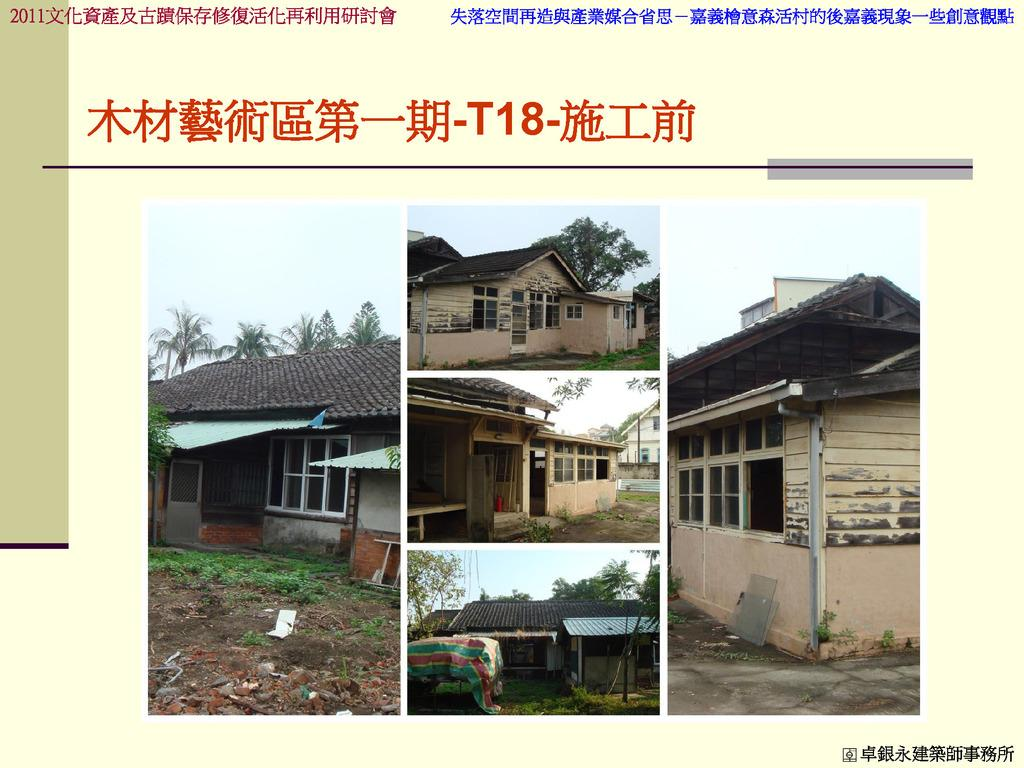What type of structures can be seen in the image? There are houses in the image. What feature is visible on the houses? There are windows visible in the image. What type of vegetation is present in the image? There are trees and grass in the image. What is on the ground in the image? There are glass pieces and objects on the ground. What is the color of the sky in the image? The sky is in white and blue color. Can you see a boy playing with a stitch in the image? There is no boy or stitch present in the image. Is there a railway visible in the image? There is no railway present in the image. 